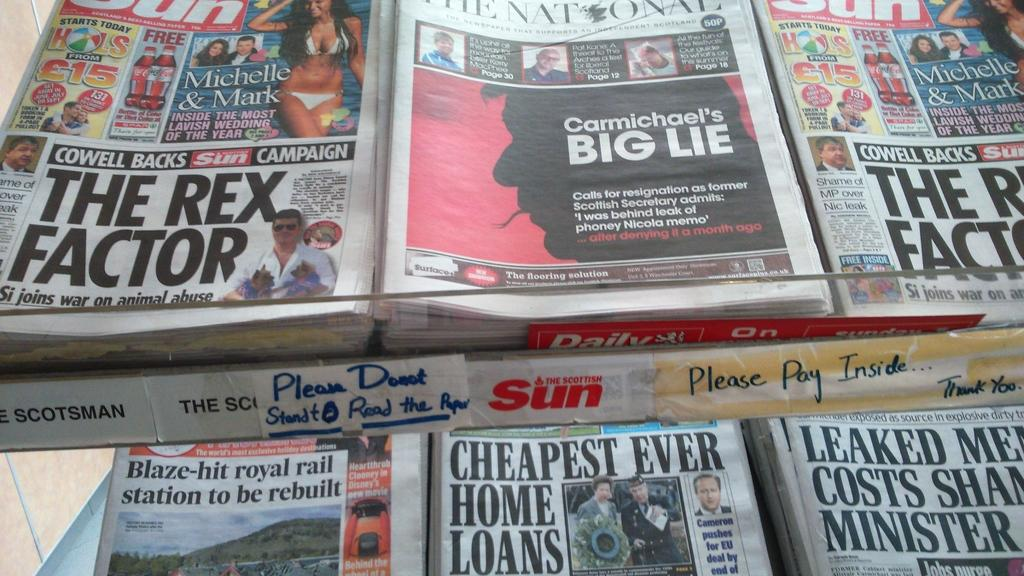Provide a one-sentence caption for the provided image. Cheapest ever home loans magazine and The scottish sun red logo. 